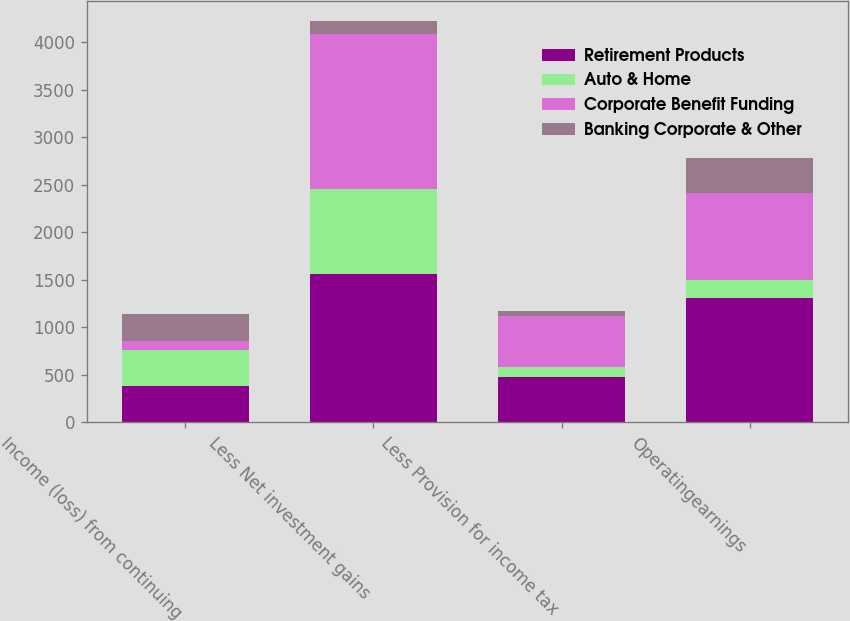<chart> <loc_0><loc_0><loc_500><loc_500><stacked_bar_chart><ecel><fcel>Income (loss) from continuing<fcel>Less Net investment gains<fcel>Less Provision for income tax<fcel>Operatingearnings<nl><fcel>Retirement Products<fcel>382<fcel>1558<fcel>480<fcel>1310<nl><fcel>Auto & Home<fcel>382<fcel>901<fcel>100<fcel>193<nl><fcel>Corporate Benefit Funding<fcel>97<fcel>1629<fcel>545<fcel>913<nl><fcel>Banking Corporate & Other<fcel>275<fcel>134<fcel>46<fcel>363<nl></chart> 